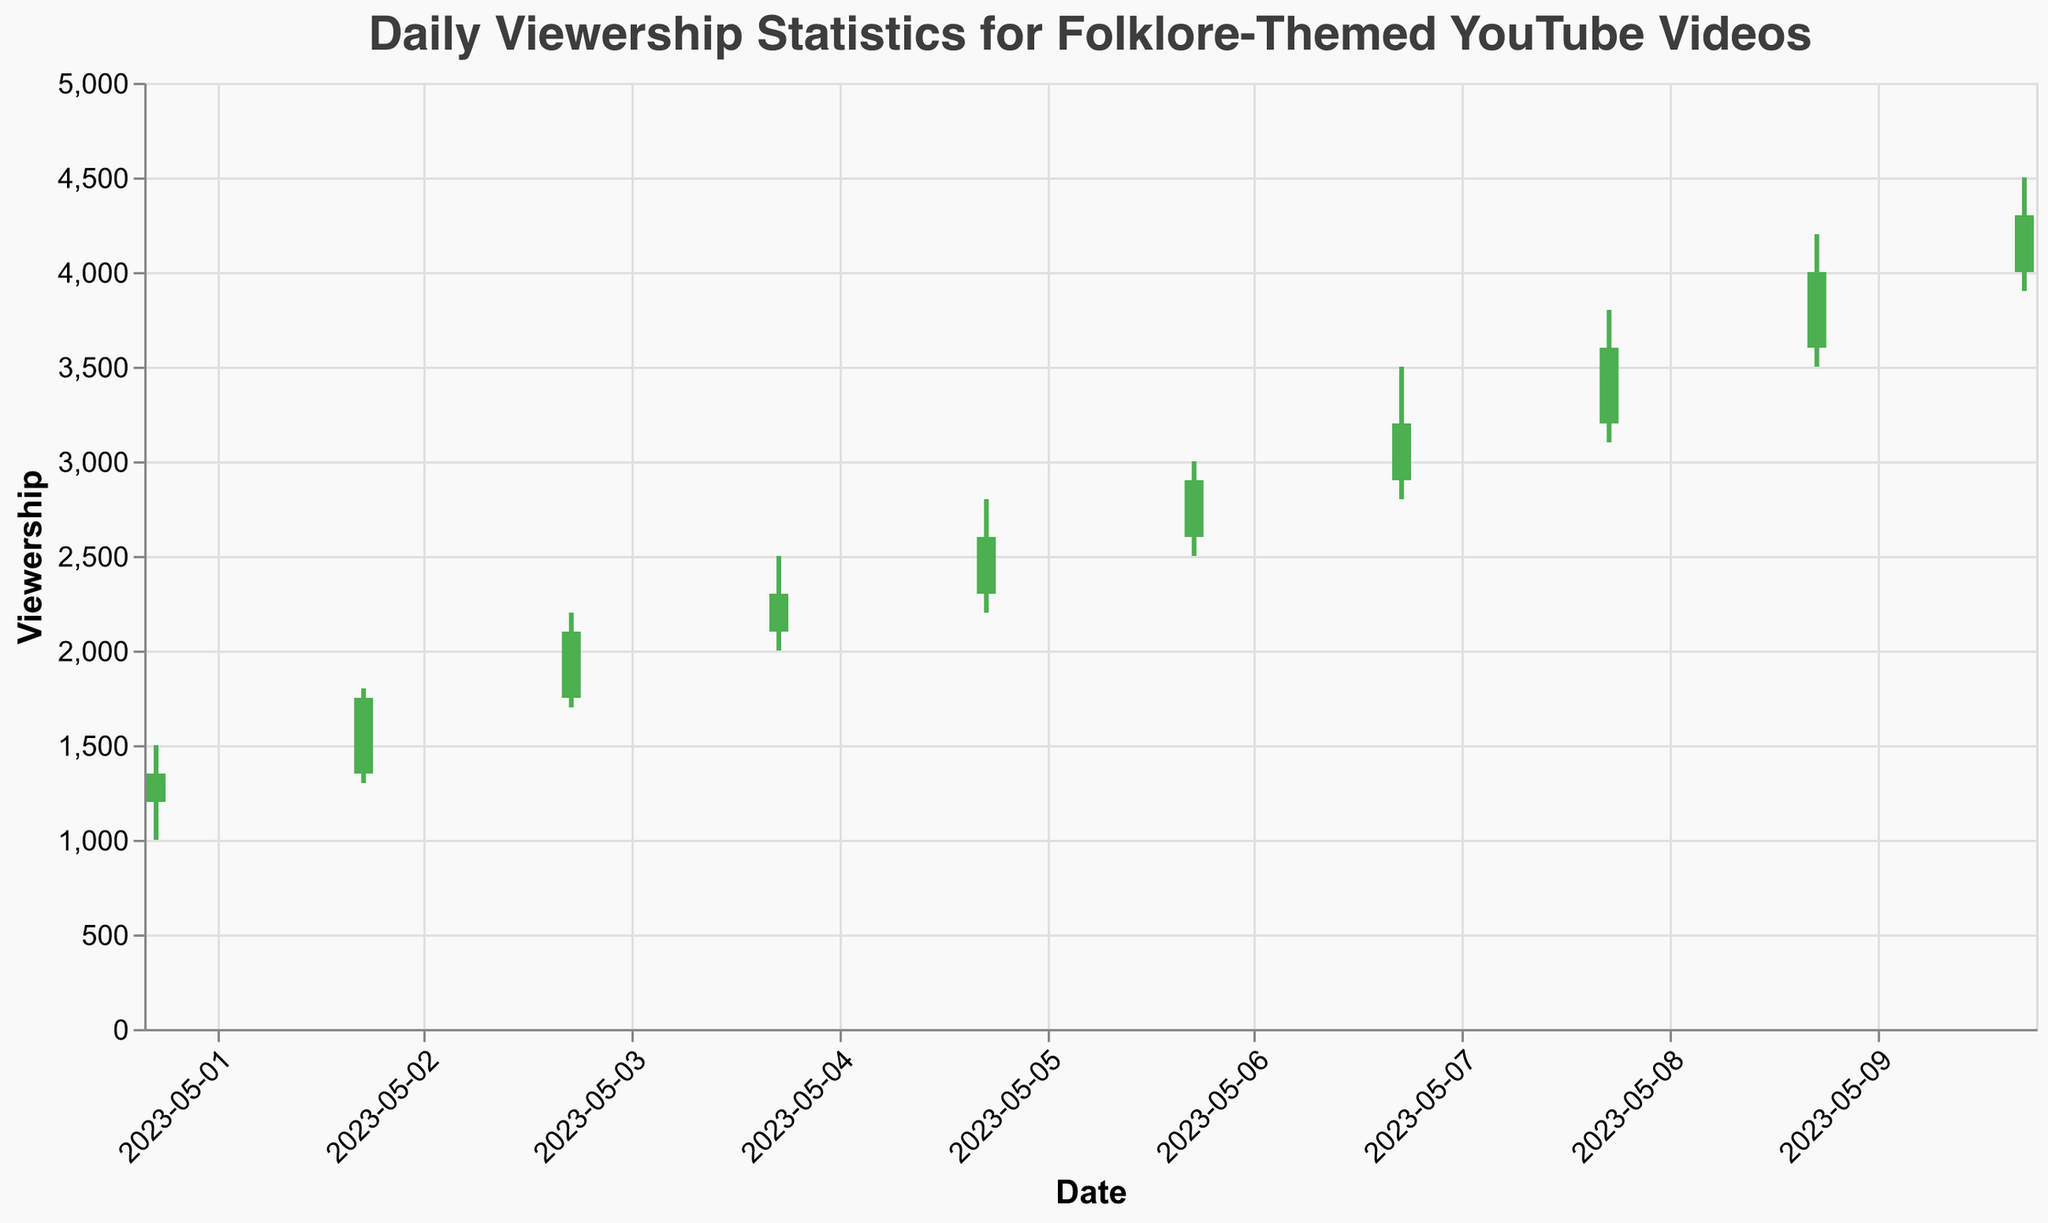What is the highest viewership recorded on any single day? The highest viewership recorded on a single day is the *High* value. Looking at the figure, the maximum *High* value is 4500 on 2023-05-10 for the video "Arthurian Legends: The Sword in the Stone."
Answer: 4500 What day had the largest difference between the opening and closing viewership? The difference between the opening and closing viewership for each day needs to be calculated. The video with the largest difference is on 2023-05-08: 3600 (closing) - 3200 (opening) = 400 viewership difference.
Answer: 2023-05-08 Which video had the smallest range of viewership (difference between High and Low) on any single day? To find the smallest range, calculate High - Low for each day and compare them. The smallest range is for the video on 2023-05-01 "The Legend of Sleepy Hollow," with a High of 1500 and a Low of 1000, resulting in a range of 500.
Answer: The Legend of Sleepy Hollow Between which dates did the viewership consistently increase every day? To find consistent increases, compare the closing viewership of each day to the previous day's closing viewership. The viewership consistently increased from 2023-05-05 to 2023-05-10.
Answer: 2023-05-05 to 2023-05-10 What was the viewership trend for the video "Japanese Yokai Legends"? Look at the *Open*, *High*, *Low*, and *Close* values for the video on 2023-05-05 and observe the trend. The *Open* value was 2300, and it increased to a *Close* value of 2600, indicating an upward trend.
Answer: Upward trend How many days had the closing viewership higher than the opening viewership? Count the days where the *Close* value is greater than the *Open* value. Such days are 2023-05-01, 2023-05-02, 2023-05-03, 2023-05-04, 2023-05-05, 2023-05-06, 2023-05-07, 2023-05-08, and 2023-05-09, making 9 days in total.
Answer: 9 days On which dates did the viewership exceed 4000? Look for days where either *High* or *Close* viewership values are above 4000. The dates that meet this condition are 2023-05-09 and 2023-05-10.
Answer: 2023-05-09 and 2023-05-10 What is the average closing viewership for the entire period? Sum all the closing values and divide by the number of days (10). The sum of the closing values is 1350 + 1750 + 2100 + 2300 + 2600 + 2900 + 3200 + 3600 + 4000 + 4300 = 28100. Therefore, the average closing viewership is 28100 / 10 = 2810.
Answer: 2810 Which day had the smallest viewership fluctuation (difference between High and Low values)? Calculate the difference between *High* and *Low* for each day and find the day with the smallest difference. On 2023-05-01, the viewership fluctuation is 1500 - 1000 = 500, which is the smallest.
Answer: 2023-05-01 